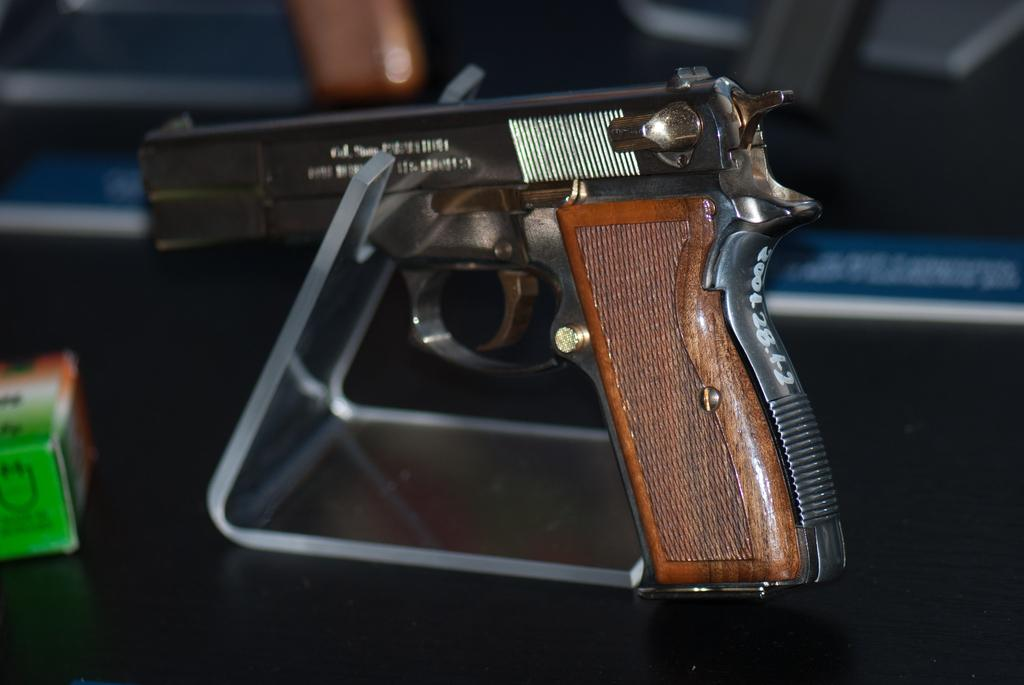What is the main object in the image? There is a gun in the image. Is there any additional furniture or equipment in the image? Yes, there is a stand in the image. Can you describe the item on the left side of the gun? There is an item on an object on the left side of the gun. What type of rain can be seen falling from the sky in the image? There is no rain visible in the image; it only features a gun and a stand. Can you describe the flight of the bird in the image? There is no bird present in the image, so it is not possible to describe its flight. 